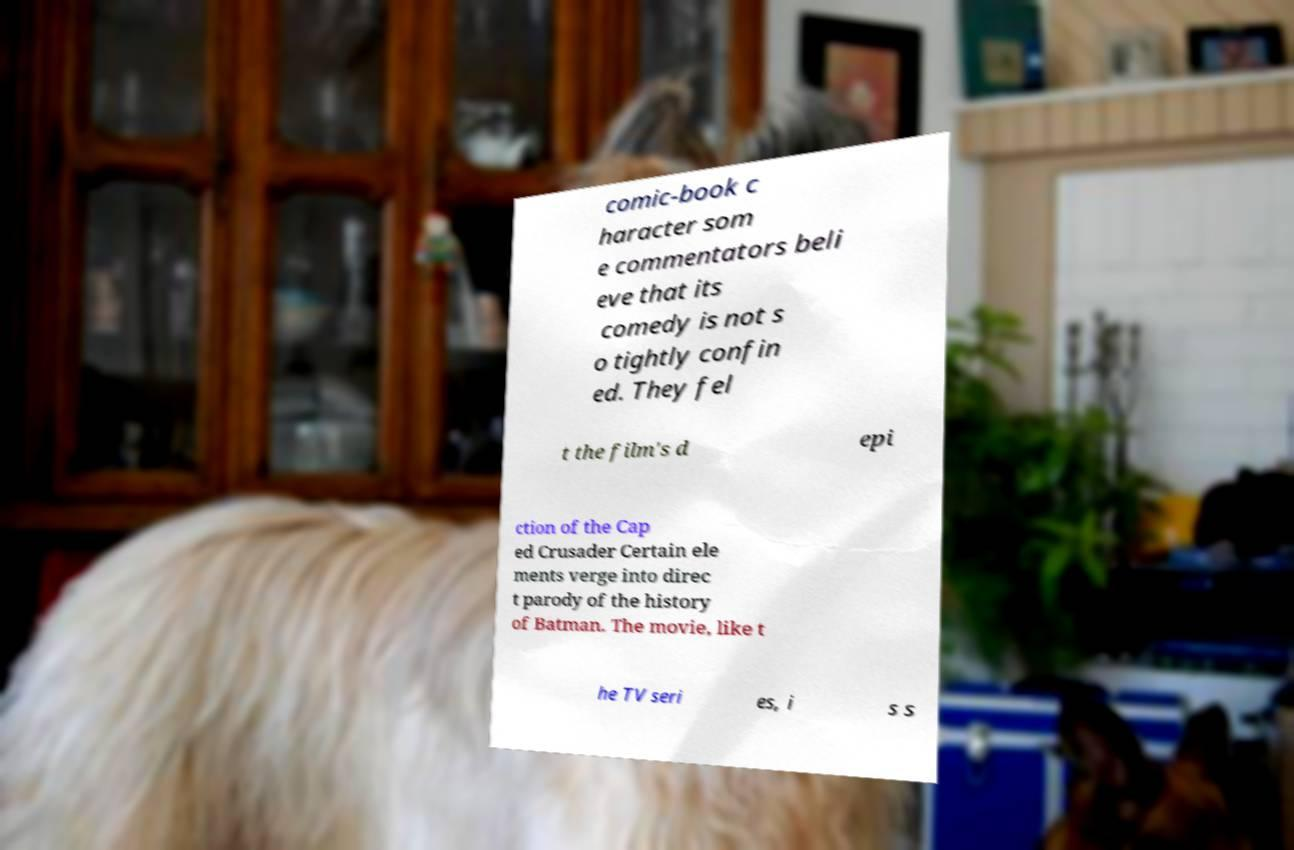There's text embedded in this image that I need extracted. Can you transcribe it verbatim? comic-book c haracter som e commentators beli eve that its comedy is not s o tightly confin ed. They fel t the film's d epi ction of the Cap ed Crusader Certain ele ments verge into direc t parody of the history of Batman. The movie, like t he TV seri es, i s s 